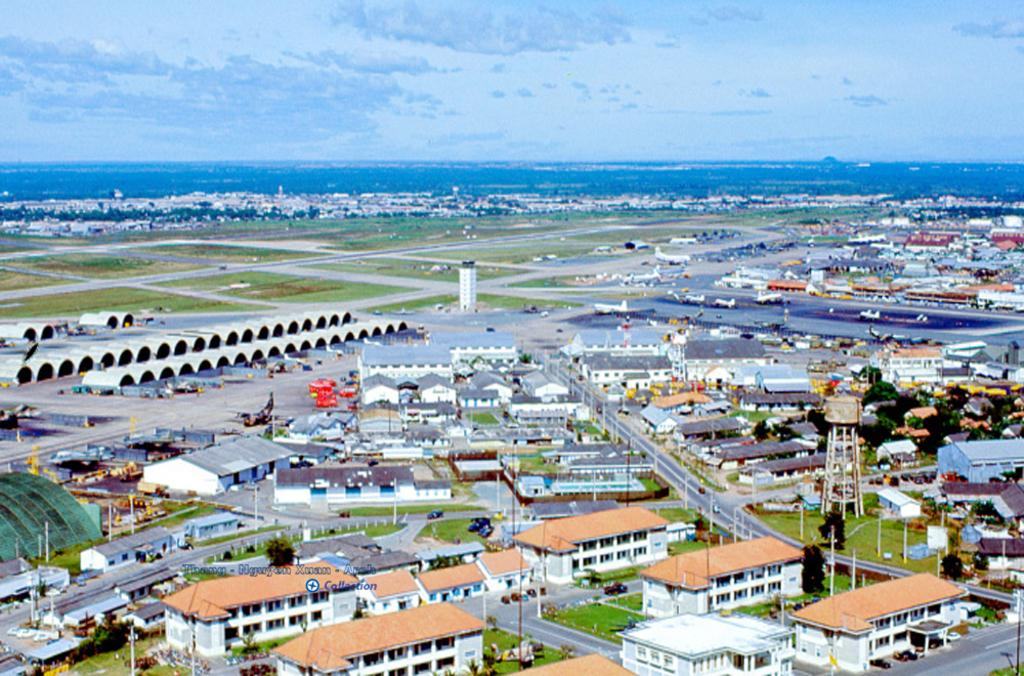What type of structures can be seen in the image? There are buildings in the image. What is the primary mode of transportation visible in the image? There are vehicles in the image. What type of vegetation is present in the image? There are trees and grass in the image. What is the condition of the sky in the image? The sky is cloudy in the image. What type of meal is being prepared in the image? There is no indication of a meal being prepared in the image. Are there any pets visible in the image? There is no mention of pets in the provided facts, so it cannot be determined if any are present in the image. 